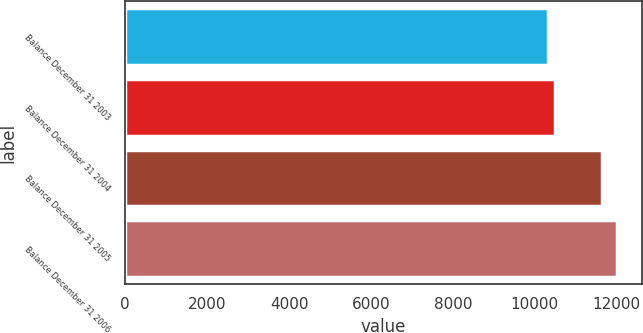Convert chart. <chart><loc_0><loc_0><loc_500><loc_500><bar_chart><fcel>Balance December 31 2003<fcel>Balance December 31 2004<fcel>Balance December 31 2005<fcel>Balance December 31 2006<nl><fcel>10317<fcel>10486.1<fcel>11631<fcel>12008<nl></chart> 